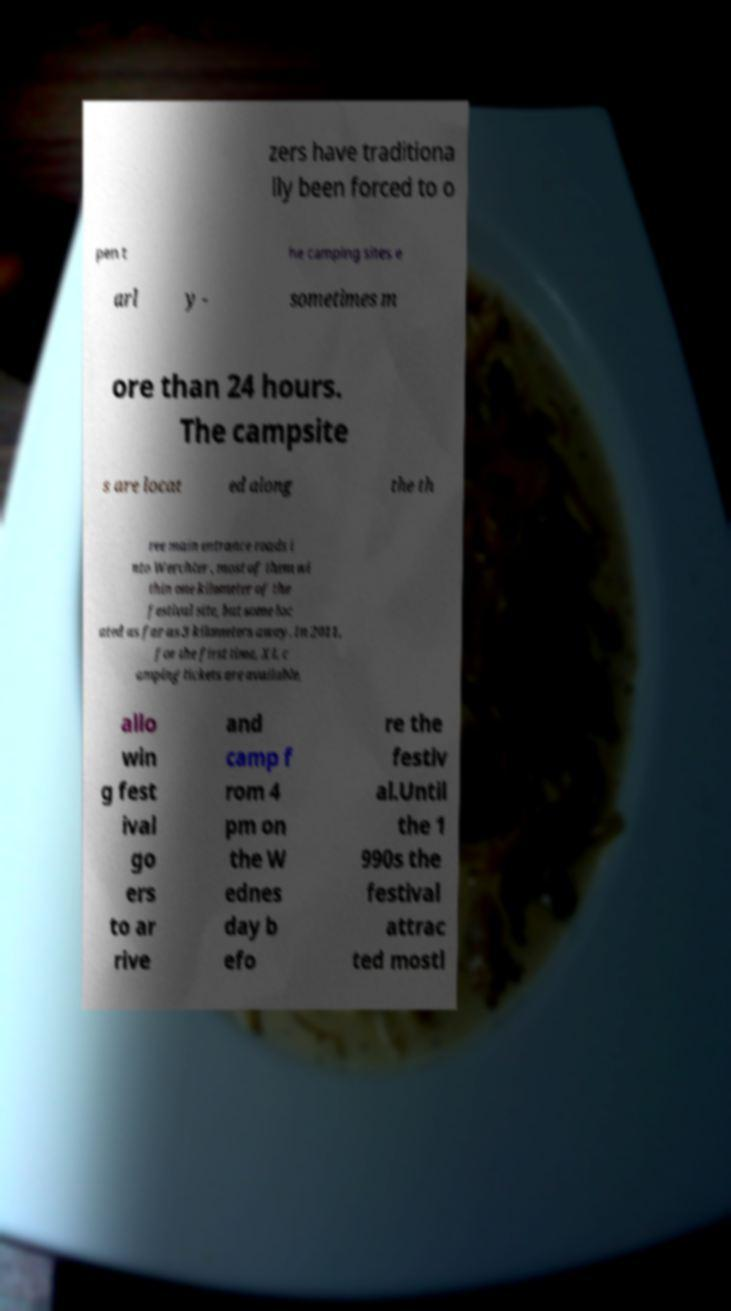Can you read and provide the text displayed in the image?This photo seems to have some interesting text. Can you extract and type it out for me? zers have traditiona lly been forced to o pen t he camping sites e arl y - sometimes m ore than 24 hours. The campsite s are locat ed along the th ree main entrance roads i nto Werchter , most of them wi thin one kilometer of the festival site, but some loc ated as far as 3 kilometers away. In 2011, for the first time, XL c amping tickets are available, allo win g fest ival go ers to ar rive and camp f rom 4 pm on the W ednes day b efo re the festiv al.Until the 1 990s the festival attrac ted mostl 